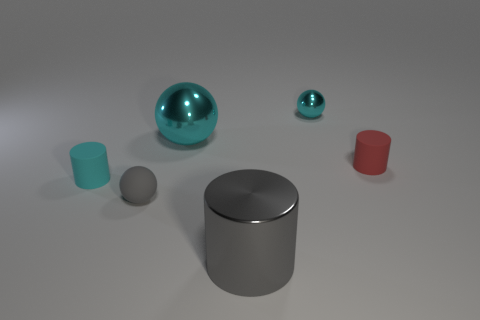What number of tiny matte cylinders are right of the small cyan sphere? 1 